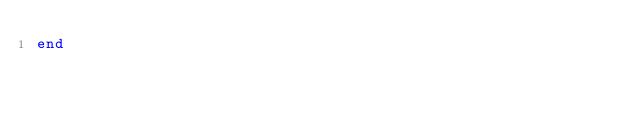Convert code to text. <code><loc_0><loc_0><loc_500><loc_500><_Ruby_>end
</code> 